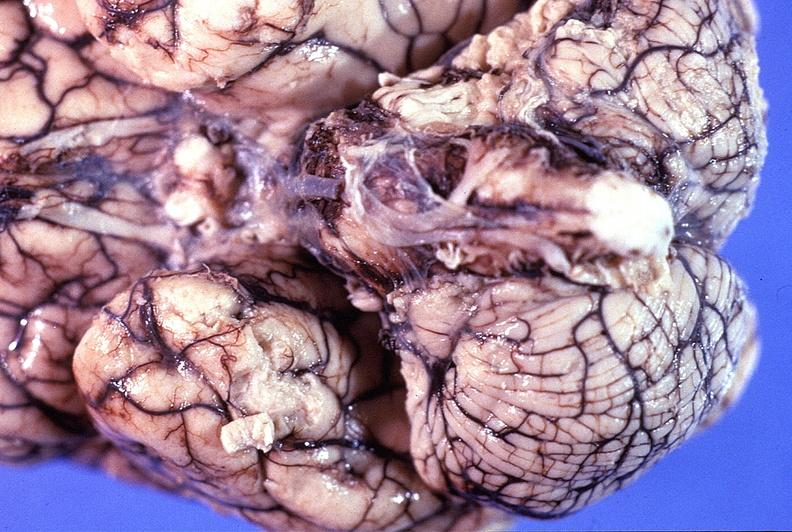does this image show normal brain?
Answer the question using a single word or phrase. Yes 